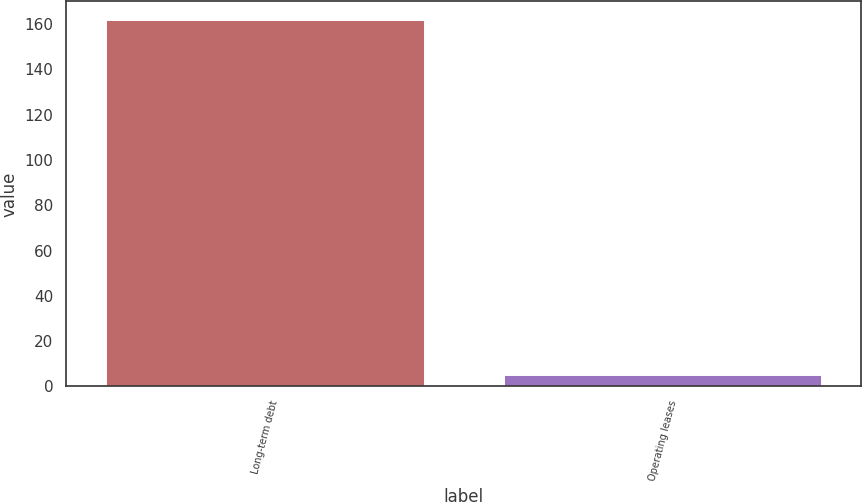<chart> <loc_0><loc_0><loc_500><loc_500><bar_chart><fcel>Long-term debt<fcel>Operating leases<nl><fcel>162<fcel>5<nl></chart> 